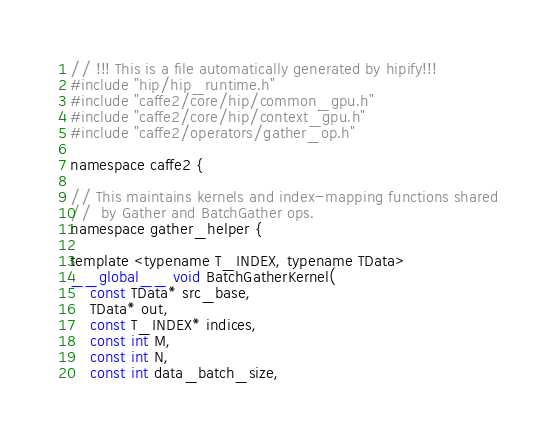<code> <loc_0><loc_0><loc_500><loc_500><_Cuda_>// !!! This is a file automatically generated by hipify!!!
#include "hip/hip_runtime.h"
#include "caffe2/core/hip/common_gpu.h"
#include "caffe2/core/hip/context_gpu.h"
#include "caffe2/operators/gather_op.h"

namespace caffe2 {

// This maintains kernels and index-mapping functions shared
//  by Gather and BatchGather ops.
namespace gather_helper {

template <typename T_INDEX, typename TData>
__global__ void BatchGatherKernel(
    const TData* src_base,
    TData* out,
    const T_INDEX* indices,
    const int M,
    const int N,
    const int data_batch_size,</code> 